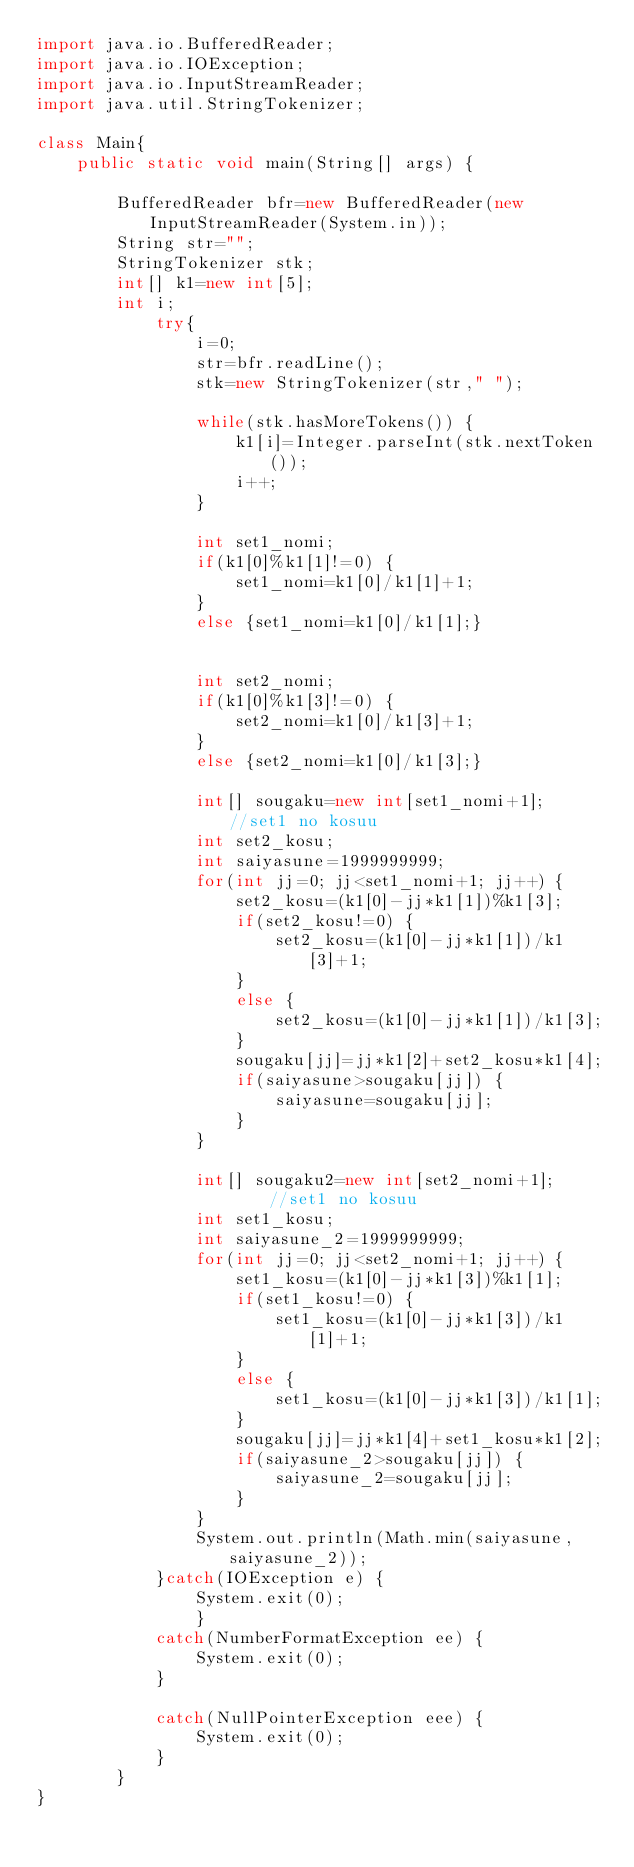Convert code to text. <code><loc_0><loc_0><loc_500><loc_500><_Java_>import java.io.BufferedReader;
import java.io.IOException;
import java.io.InputStreamReader;
import java.util.StringTokenizer;

class Main{
	public static void main(String[] args) {

		BufferedReader bfr=new BufferedReader(new InputStreamReader(System.in));
		String str="";
		StringTokenizer stk;
		int[] k1=new int[5];
		int i;
			try{
				i=0;
				str=bfr.readLine();
				stk=new StringTokenizer(str," ");

				while(stk.hasMoreTokens()) {
					k1[i]=Integer.parseInt(stk.nextToken());
					i++;
				}

				int set1_nomi;
				if(k1[0]%k1[1]!=0) {
					set1_nomi=k1[0]/k1[1]+1;
				}
				else {set1_nomi=k1[0]/k1[1];}


				int set2_nomi;
				if(k1[0]%k1[3]!=0) {
					set2_nomi=k1[0]/k1[3]+1;
				}
				else {set2_nomi=k1[0]/k1[3];}

				int[] sougaku=new int[set1_nomi+1];		//set1 no kosuu
				int set2_kosu;
				int saiyasune=1999999999;
				for(int jj=0; jj<set1_nomi+1; jj++) {
					set2_kosu=(k1[0]-jj*k1[1])%k1[3];
					if(set2_kosu!=0) {
						set2_kosu=(k1[0]-jj*k1[1])/k1[3]+1;
					}
					else {
						set2_kosu=(k1[0]-jj*k1[1])/k1[3];
					}
					sougaku[jj]=jj*k1[2]+set2_kosu*k1[4];
					if(saiyasune>sougaku[jj]) {
						saiyasune=sougaku[jj];
					}
				}

				int[] sougaku2=new int[set2_nomi+1];		//set1 no kosuu
				int set1_kosu;
				int saiyasune_2=1999999999;
				for(int jj=0; jj<set2_nomi+1; jj++) {
					set1_kosu=(k1[0]-jj*k1[3])%k1[1];
					if(set1_kosu!=0) {
						set1_kosu=(k1[0]-jj*k1[3])/k1[1]+1;
					}
					else {
						set1_kosu=(k1[0]-jj*k1[3])/k1[1];
					}
					sougaku[jj]=jj*k1[4]+set1_kosu*k1[2];
					if(saiyasune_2>sougaku[jj]) {
						saiyasune_2=sougaku[jj];
					}
				}
				System.out.println(Math.min(saiyasune, saiyasune_2));
			}catch(IOException e) {
				System.exit(0);
				}
			catch(NumberFormatException ee) {
				System.exit(0);
			}

			catch(NullPointerException eee) {
				System.exit(0);
			}
		}
}
</code> 